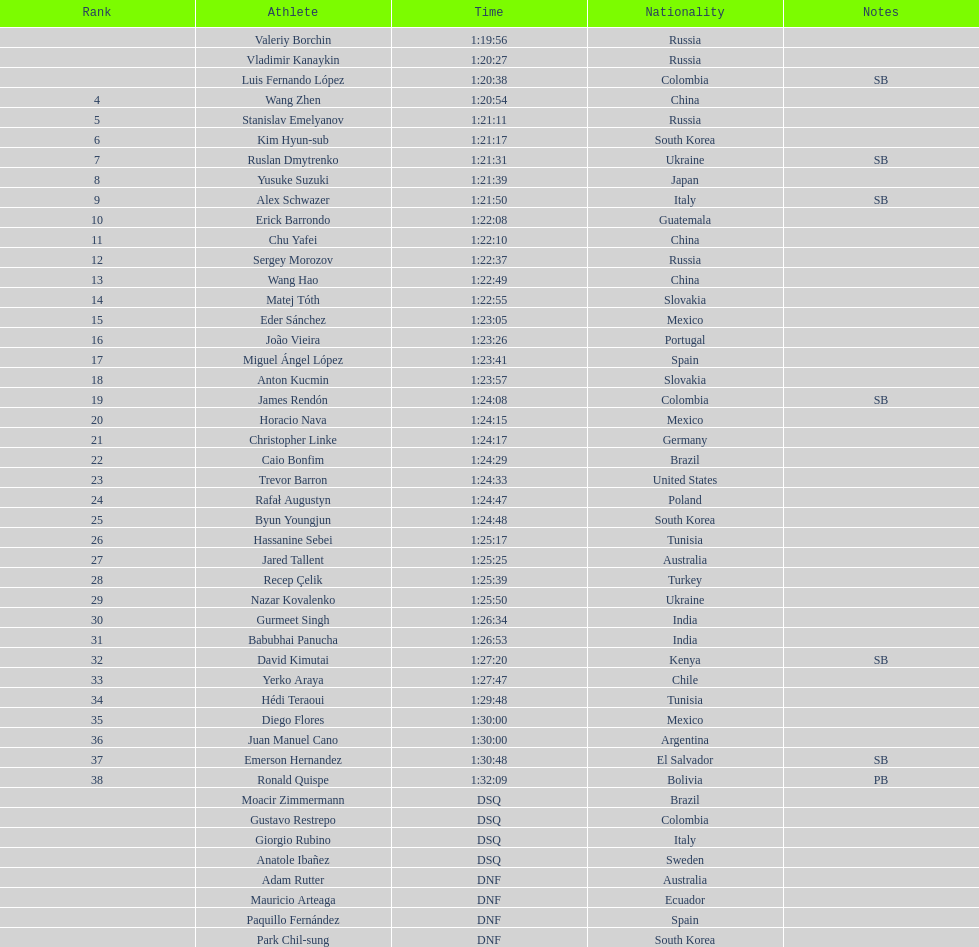Which athlete is the only american to be ranked in the 20km? Trevor Barron. 